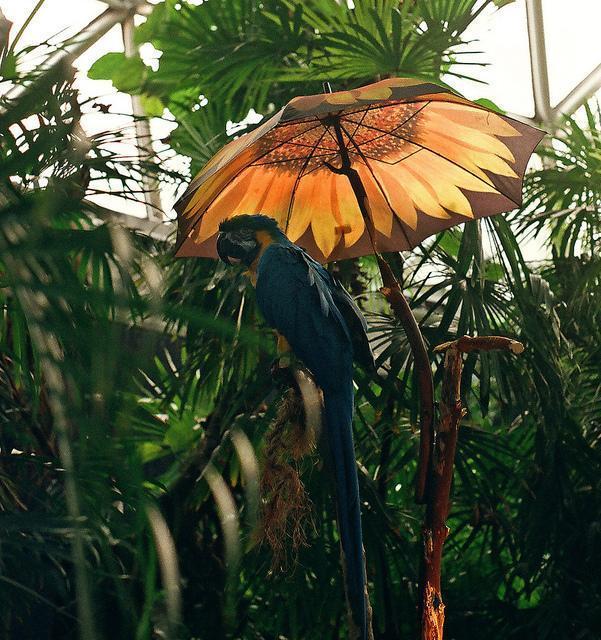Verify the accuracy of this image caption: "The umbrella is above the bird.".
Answer yes or no. Yes. 